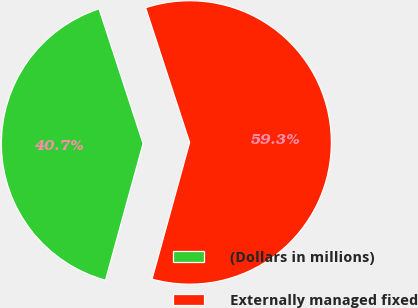<chart> <loc_0><loc_0><loc_500><loc_500><pie_chart><fcel>(Dollars in millions)<fcel>Externally managed fixed<nl><fcel>40.7%<fcel>59.3%<nl></chart> 